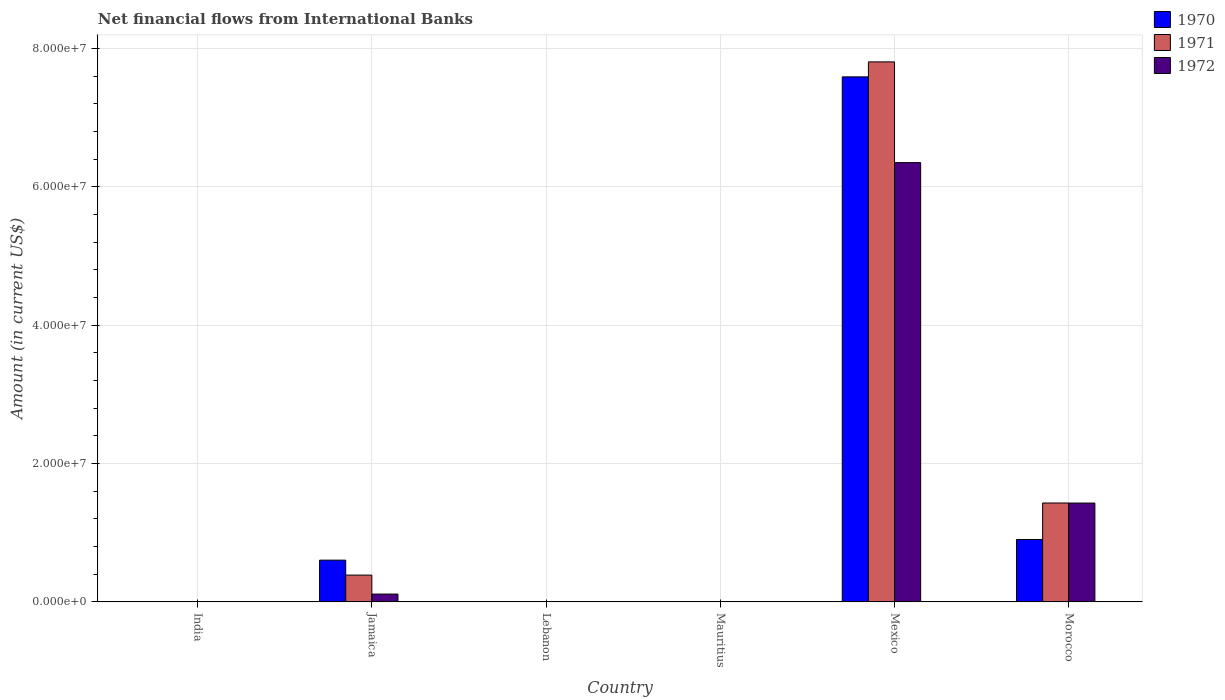What is the label of the 3rd group of bars from the left?
Your answer should be compact. Lebanon. In how many cases, is the number of bars for a given country not equal to the number of legend labels?
Give a very brief answer. 3. Across all countries, what is the maximum net financial aid flows in 1971?
Offer a terse response. 7.81e+07. In which country was the net financial aid flows in 1971 maximum?
Offer a very short reply. Mexico. What is the total net financial aid flows in 1972 in the graph?
Provide a short and direct response. 7.89e+07. What is the difference between the net financial aid flows in 1970 in Lebanon and the net financial aid flows in 1972 in Mexico?
Keep it short and to the point. -6.35e+07. What is the average net financial aid flows in 1971 per country?
Ensure brevity in your answer.  1.60e+07. What is the difference between the net financial aid flows of/in 1970 and net financial aid flows of/in 1971 in Morocco?
Offer a very short reply. -5.28e+06. In how many countries, is the net financial aid flows in 1972 greater than 20000000 US$?
Provide a short and direct response. 1. What is the ratio of the net financial aid flows in 1970 in Jamaica to that in Mexico?
Make the answer very short. 0.08. Is the net financial aid flows in 1972 in Jamaica less than that in Morocco?
Offer a terse response. Yes. What is the difference between the highest and the second highest net financial aid flows in 1970?
Ensure brevity in your answer.  6.69e+07. What is the difference between the highest and the lowest net financial aid flows in 1970?
Your answer should be very brief. 7.59e+07. Is it the case that in every country, the sum of the net financial aid flows in 1970 and net financial aid flows in 1971 is greater than the net financial aid flows in 1972?
Provide a succinct answer. No. How many countries are there in the graph?
Your response must be concise. 6. What is the difference between two consecutive major ticks on the Y-axis?
Provide a short and direct response. 2.00e+07. Are the values on the major ticks of Y-axis written in scientific E-notation?
Your response must be concise. Yes. Does the graph contain any zero values?
Ensure brevity in your answer.  Yes. Where does the legend appear in the graph?
Provide a short and direct response. Top right. How are the legend labels stacked?
Your answer should be compact. Vertical. What is the title of the graph?
Offer a very short reply. Net financial flows from International Banks. What is the Amount (in current US$) in 1970 in India?
Give a very brief answer. 0. What is the Amount (in current US$) of 1972 in India?
Ensure brevity in your answer.  0. What is the Amount (in current US$) in 1970 in Jamaica?
Your response must be concise. 6.04e+06. What is the Amount (in current US$) of 1971 in Jamaica?
Ensure brevity in your answer.  3.88e+06. What is the Amount (in current US$) of 1972 in Jamaica?
Your answer should be very brief. 1.14e+06. What is the Amount (in current US$) in 1970 in Lebanon?
Offer a terse response. 0. What is the Amount (in current US$) in 1971 in Mauritius?
Provide a succinct answer. 0. What is the Amount (in current US$) in 1970 in Mexico?
Your answer should be very brief. 7.59e+07. What is the Amount (in current US$) in 1971 in Mexico?
Your response must be concise. 7.81e+07. What is the Amount (in current US$) in 1972 in Mexico?
Give a very brief answer. 6.35e+07. What is the Amount (in current US$) of 1970 in Morocco?
Provide a succinct answer. 9.03e+06. What is the Amount (in current US$) in 1971 in Morocco?
Your response must be concise. 1.43e+07. What is the Amount (in current US$) of 1972 in Morocco?
Your answer should be compact. 1.43e+07. Across all countries, what is the maximum Amount (in current US$) in 1970?
Offer a terse response. 7.59e+07. Across all countries, what is the maximum Amount (in current US$) in 1971?
Provide a short and direct response. 7.81e+07. Across all countries, what is the maximum Amount (in current US$) in 1972?
Your answer should be compact. 6.35e+07. What is the total Amount (in current US$) of 1970 in the graph?
Your response must be concise. 9.10e+07. What is the total Amount (in current US$) in 1971 in the graph?
Your answer should be compact. 9.63e+07. What is the total Amount (in current US$) of 1972 in the graph?
Provide a succinct answer. 7.89e+07. What is the difference between the Amount (in current US$) in 1970 in Jamaica and that in Mexico?
Provide a succinct answer. -6.99e+07. What is the difference between the Amount (in current US$) of 1971 in Jamaica and that in Mexico?
Ensure brevity in your answer.  -7.42e+07. What is the difference between the Amount (in current US$) in 1972 in Jamaica and that in Mexico?
Ensure brevity in your answer.  -6.24e+07. What is the difference between the Amount (in current US$) of 1970 in Jamaica and that in Morocco?
Make the answer very short. -2.99e+06. What is the difference between the Amount (in current US$) of 1971 in Jamaica and that in Morocco?
Give a very brief answer. -1.04e+07. What is the difference between the Amount (in current US$) in 1972 in Jamaica and that in Morocco?
Provide a short and direct response. -1.32e+07. What is the difference between the Amount (in current US$) of 1970 in Mexico and that in Morocco?
Provide a short and direct response. 6.69e+07. What is the difference between the Amount (in current US$) of 1971 in Mexico and that in Morocco?
Keep it short and to the point. 6.38e+07. What is the difference between the Amount (in current US$) in 1972 in Mexico and that in Morocco?
Provide a short and direct response. 4.92e+07. What is the difference between the Amount (in current US$) in 1970 in Jamaica and the Amount (in current US$) in 1971 in Mexico?
Provide a succinct answer. -7.20e+07. What is the difference between the Amount (in current US$) in 1970 in Jamaica and the Amount (in current US$) in 1972 in Mexico?
Ensure brevity in your answer.  -5.75e+07. What is the difference between the Amount (in current US$) in 1971 in Jamaica and the Amount (in current US$) in 1972 in Mexico?
Your answer should be very brief. -5.96e+07. What is the difference between the Amount (in current US$) in 1970 in Jamaica and the Amount (in current US$) in 1971 in Morocco?
Your answer should be very brief. -8.26e+06. What is the difference between the Amount (in current US$) in 1970 in Jamaica and the Amount (in current US$) in 1972 in Morocco?
Your answer should be very brief. -8.25e+06. What is the difference between the Amount (in current US$) of 1971 in Jamaica and the Amount (in current US$) of 1972 in Morocco?
Provide a short and direct response. -1.04e+07. What is the difference between the Amount (in current US$) of 1970 in Mexico and the Amount (in current US$) of 1971 in Morocco?
Keep it short and to the point. 6.16e+07. What is the difference between the Amount (in current US$) in 1970 in Mexico and the Amount (in current US$) in 1972 in Morocco?
Your response must be concise. 6.16e+07. What is the difference between the Amount (in current US$) of 1971 in Mexico and the Amount (in current US$) of 1972 in Morocco?
Make the answer very short. 6.38e+07. What is the average Amount (in current US$) of 1970 per country?
Provide a short and direct response. 1.52e+07. What is the average Amount (in current US$) in 1971 per country?
Provide a succinct answer. 1.60e+07. What is the average Amount (in current US$) in 1972 per country?
Provide a succinct answer. 1.32e+07. What is the difference between the Amount (in current US$) in 1970 and Amount (in current US$) in 1971 in Jamaica?
Your response must be concise. 2.16e+06. What is the difference between the Amount (in current US$) in 1970 and Amount (in current US$) in 1972 in Jamaica?
Your answer should be very brief. 4.90e+06. What is the difference between the Amount (in current US$) in 1971 and Amount (in current US$) in 1972 in Jamaica?
Offer a very short reply. 2.74e+06. What is the difference between the Amount (in current US$) of 1970 and Amount (in current US$) of 1971 in Mexico?
Keep it short and to the point. -2.17e+06. What is the difference between the Amount (in current US$) of 1970 and Amount (in current US$) of 1972 in Mexico?
Your answer should be very brief. 1.24e+07. What is the difference between the Amount (in current US$) in 1971 and Amount (in current US$) in 1972 in Mexico?
Keep it short and to the point. 1.46e+07. What is the difference between the Amount (in current US$) of 1970 and Amount (in current US$) of 1971 in Morocco?
Ensure brevity in your answer.  -5.28e+06. What is the difference between the Amount (in current US$) of 1970 and Amount (in current US$) of 1972 in Morocco?
Provide a succinct answer. -5.27e+06. What is the ratio of the Amount (in current US$) in 1970 in Jamaica to that in Mexico?
Your response must be concise. 0.08. What is the ratio of the Amount (in current US$) in 1971 in Jamaica to that in Mexico?
Keep it short and to the point. 0.05. What is the ratio of the Amount (in current US$) in 1972 in Jamaica to that in Mexico?
Keep it short and to the point. 0.02. What is the ratio of the Amount (in current US$) in 1970 in Jamaica to that in Morocco?
Ensure brevity in your answer.  0.67. What is the ratio of the Amount (in current US$) in 1971 in Jamaica to that in Morocco?
Offer a terse response. 0.27. What is the ratio of the Amount (in current US$) of 1972 in Jamaica to that in Morocco?
Give a very brief answer. 0.08. What is the ratio of the Amount (in current US$) of 1970 in Mexico to that in Morocco?
Offer a terse response. 8.41. What is the ratio of the Amount (in current US$) of 1971 in Mexico to that in Morocco?
Ensure brevity in your answer.  5.46. What is the ratio of the Amount (in current US$) of 1972 in Mexico to that in Morocco?
Your answer should be very brief. 4.44. What is the difference between the highest and the second highest Amount (in current US$) in 1970?
Your answer should be very brief. 6.69e+07. What is the difference between the highest and the second highest Amount (in current US$) of 1971?
Your answer should be very brief. 6.38e+07. What is the difference between the highest and the second highest Amount (in current US$) in 1972?
Your answer should be compact. 4.92e+07. What is the difference between the highest and the lowest Amount (in current US$) of 1970?
Keep it short and to the point. 7.59e+07. What is the difference between the highest and the lowest Amount (in current US$) of 1971?
Your response must be concise. 7.81e+07. What is the difference between the highest and the lowest Amount (in current US$) in 1972?
Ensure brevity in your answer.  6.35e+07. 